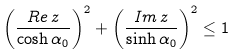<formula> <loc_0><loc_0><loc_500><loc_500>\left ( \frac { R e \, z } { \cosh \alpha _ { 0 } } \right ) ^ { 2 } + \left ( \frac { I m \, z } { \sinh \alpha _ { 0 } } \right ) ^ { 2 } \leq 1 \,</formula> 